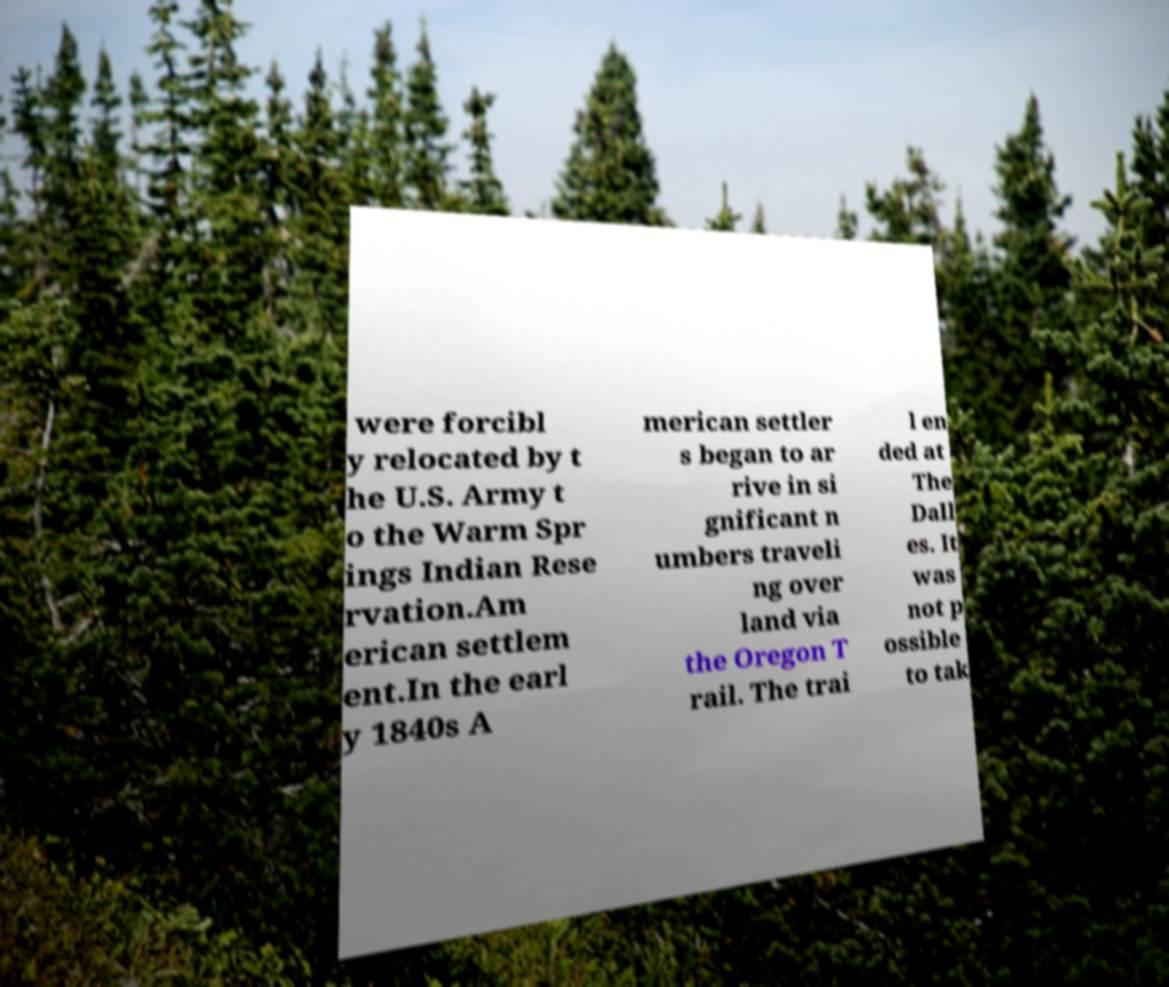Can you accurately transcribe the text from the provided image for me? were forcibl y relocated by t he U.S. Army t o the Warm Spr ings Indian Rese rvation.Am erican settlem ent.In the earl y 1840s A merican settler s began to ar rive in si gnificant n umbers traveli ng over land via the Oregon T rail. The trai l en ded at The Dall es. It was not p ossible to tak 